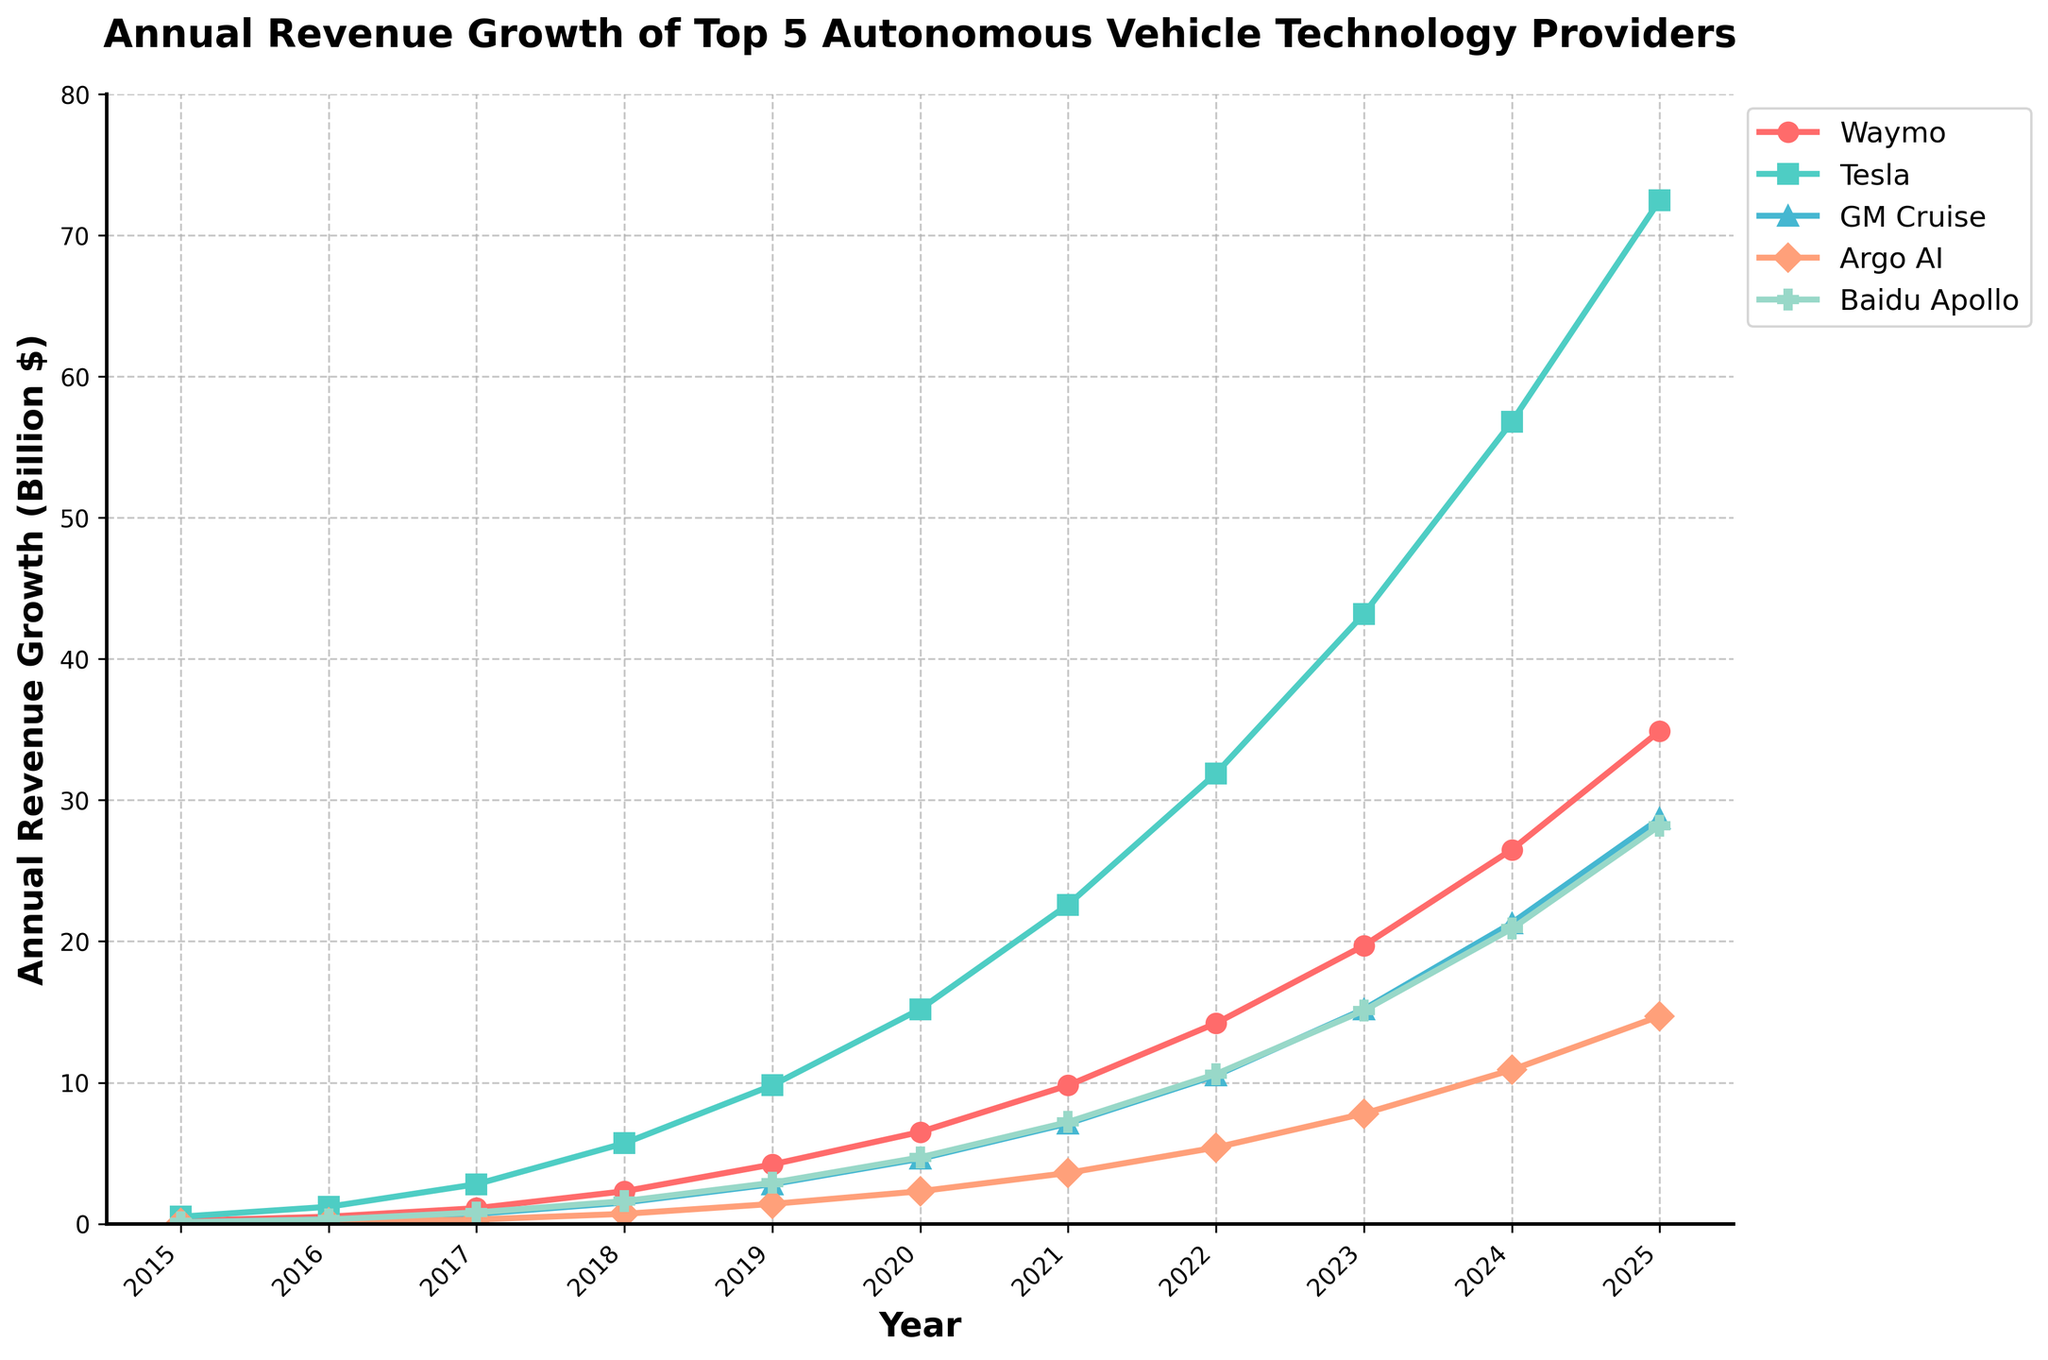Which company had the highest revenue growth in 2025? To find out which company had the highest revenue growth in 2025, check the figure for the highest point in the 2025 timeline across all lines representing the companies. The highest point in 2025 is 72.5, representing Tesla.
Answer: Tesla What was the average revenue growth of GM Cruise from 2015 to 2025? First, sum up GM Cruise's revenue growth from each year: 0.1 + 0.3 + 0.7 + 1.5 + 2.8 + 4.6 + 7.1 + 10.5 + 15.2 + 21.3 + 28.7. The total is 92.8. Now, divide this by the number of years (11): 92.8 / 11 = 8.44.
Answer: 8.44 How much more revenue growth did Tesla have compared to Waymo in 2023? Find the revenue growth for Tesla and Waymo in 2023. Tesla had 43.2 and Waymo had 19.7. Subtract Waymo's growth from Tesla's: 43.2 - 19.7 = 23.5.
Answer: 23.5 Which year saw the highest revenue growth for Argo AI? Look for the highest point in the line representing Argo AI. The highest value is 14.7, which occurs in 2025.
Answer: 2025 Between 2017 and 2018, which company saw the biggest increase in revenue growth? Calculate the increase for each company between 2017 and 2018. Waymo: 2.3 - 1.1 = 1.2, Tesla: 5.7 - 2.8 = 2.9, GM Cruise: 1.5 - 0.7 = 0.8, Argo AI: 0.7 - 0.3 = 0.4, Baidu Apollo: 1.6 - 0.8 = 0.8. Tesla saw the biggest increase of 2.9.
Answer: Tesla Did Baidu Apollo achieve a higher revenue growth than Argo AI in 2020? Compare the 2020 revenue growth values for Baidu Apollo (4.7) and Argo AI (2.3). Since 4.7 > 2.3, Baidu Apollo had higher revenue growth.
Answer: Yes What was the total revenue growth for all companies in 2019? Add the revenue growth for all companies in 2019: 4.2 (Waymo) + 9.8 (Tesla) + 2.8 (GM Cruise) + 1.4 (Argo AI) + 2.9 (Baidu Apollo) = 21.1.
Answer: 21.1 Which company had the lowest revenue growth in 2021? Check the value points for each company in 2021. The lowest value is Argo AI with 3.6.
Answer: Argo AI 